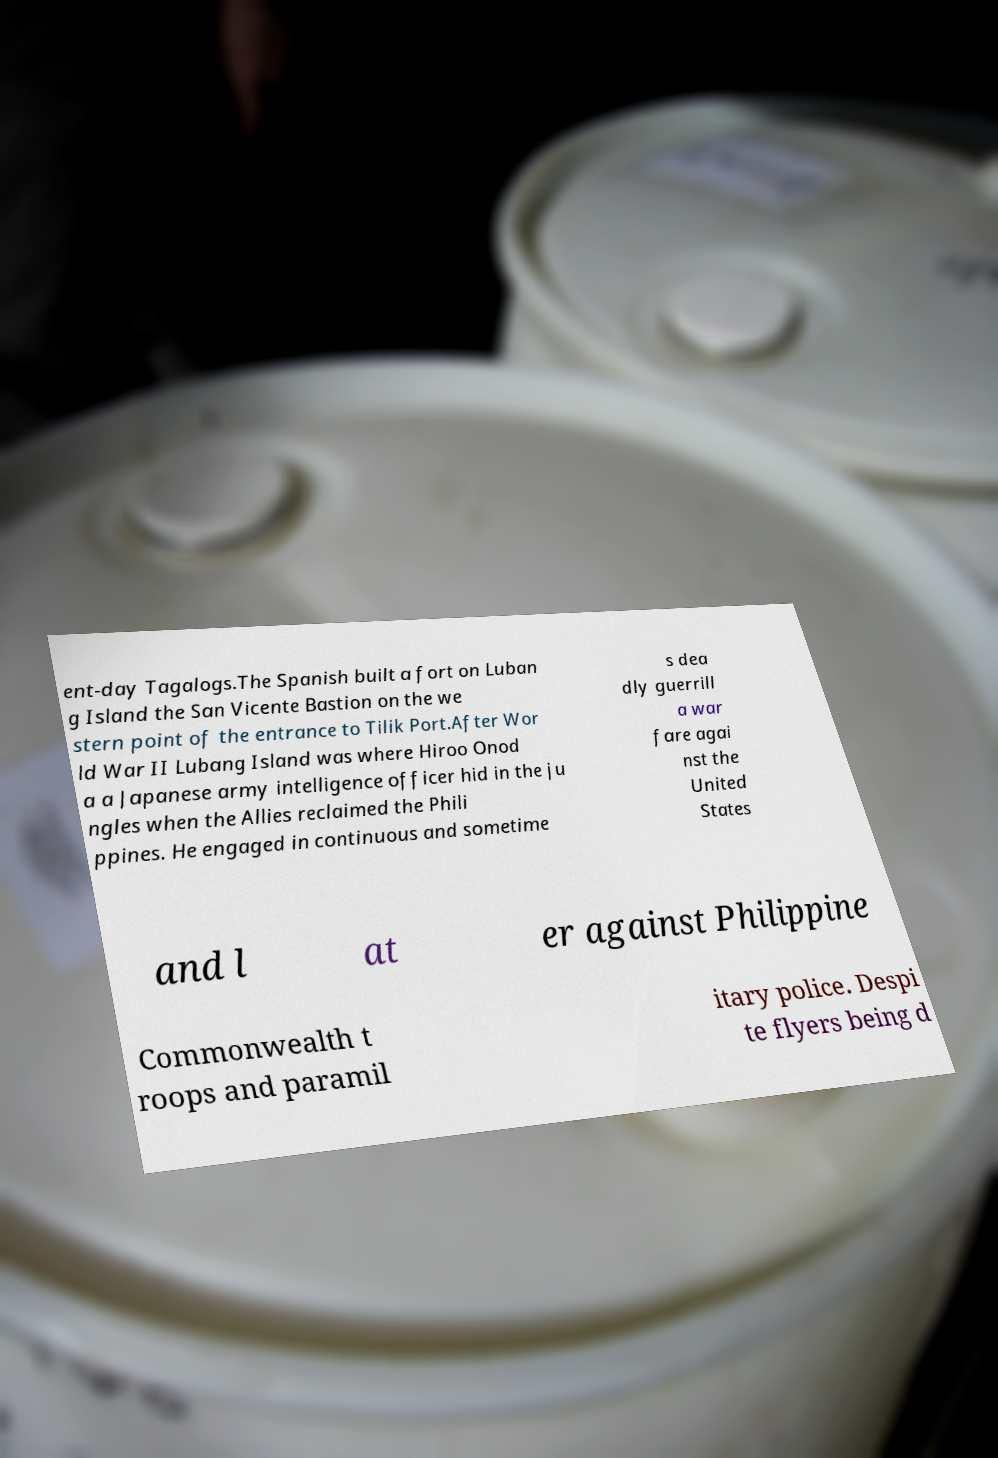Can you accurately transcribe the text from the provided image for me? ent-day Tagalogs.The Spanish built a fort on Luban g Island the San Vicente Bastion on the we stern point of the entrance to Tilik Port.After Wor ld War II Lubang Island was where Hiroo Onod a a Japanese army intelligence officer hid in the ju ngles when the Allies reclaimed the Phili ppines. He engaged in continuous and sometime s dea dly guerrill a war fare agai nst the United States and l at er against Philippine Commonwealth t roops and paramil itary police. Despi te flyers being d 